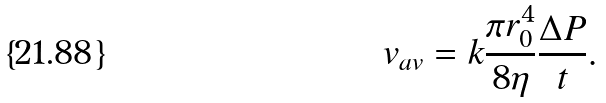Convert formula to latex. <formula><loc_0><loc_0><loc_500><loc_500>v _ { a v } = k \frac { \pi r _ { 0 } ^ { 4 } } { 8 \eta } \frac { \Delta P } { t } .</formula> 